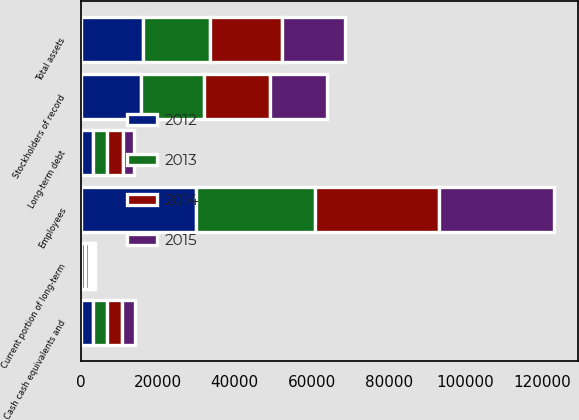<chart> <loc_0><loc_0><loc_500><loc_500><stacked_bar_chart><ecel><fcel>Cash cash equivalents and<fcel>Total assets<fcel>Current portion of long-term<fcel>Long-term debt<fcel>Employees<fcel>Stockholders of record<nl><fcel>2015<fcel>3490<fcel>16431<fcel>631<fcel>2978<fcel>29865<fcel>14910<nl><fcel>2012<fcel>3218<fcel>16230<fcel>1000<fcel>3120<fcel>29977<fcel>15563<nl><fcel>2013<fcel>3541<fcel>17372<fcel>1001<fcel>3630<fcel>31003<fcel>16361<nl><fcel>2014<fcel>3829<fcel>18554<fcel>1000<fcel>4145<fcel>32209<fcel>17213<nl></chart> 